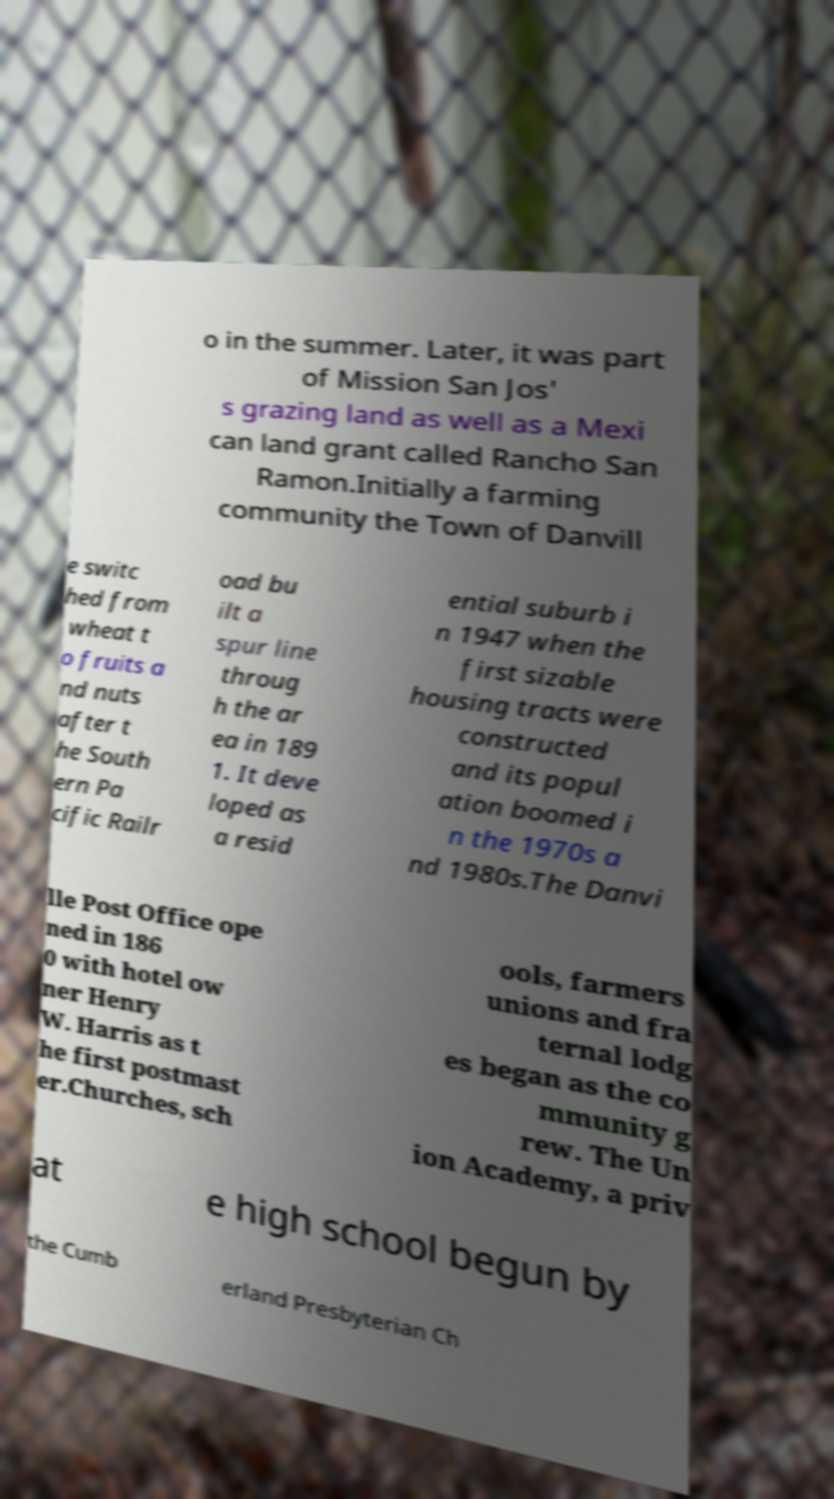Can you read and provide the text displayed in the image?This photo seems to have some interesting text. Can you extract and type it out for me? o in the summer. Later, it was part of Mission San Jos' s grazing land as well as a Mexi can land grant called Rancho San Ramon.Initially a farming community the Town of Danvill e switc hed from wheat t o fruits a nd nuts after t he South ern Pa cific Railr oad bu ilt a spur line throug h the ar ea in 189 1. It deve loped as a resid ential suburb i n 1947 when the first sizable housing tracts were constructed and its popul ation boomed i n the 1970s a nd 1980s.The Danvi lle Post Office ope ned in 186 0 with hotel ow ner Henry W. Harris as t he first postmast er.Churches, sch ools, farmers unions and fra ternal lodg es began as the co mmunity g rew. The Un ion Academy, a priv at e high school begun by the Cumb erland Presbyterian Ch 